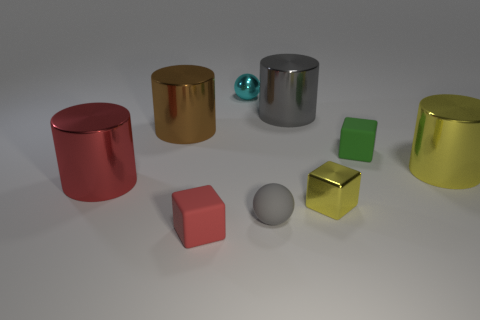Subtract all small matte cubes. How many cubes are left? 1 Subtract 4 cylinders. How many cylinders are left? 0 Subtract all red cylinders. How many cylinders are left? 3 Add 1 green things. How many objects exist? 10 Subtract all blocks. How many objects are left? 6 Subtract all cyan cylinders. Subtract all brown balls. How many cylinders are left? 4 Subtract all brown cylinders. How many purple spheres are left? 0 Subtract all large green cylinders. Subtract all gray things. How many objects are left? 7 Add 3 large brown metallic cylinders. How many large brown metallic cylinders are left? 4 Add 6 tiny yellow cubes. How many tiny yellow cubes exist? 7 